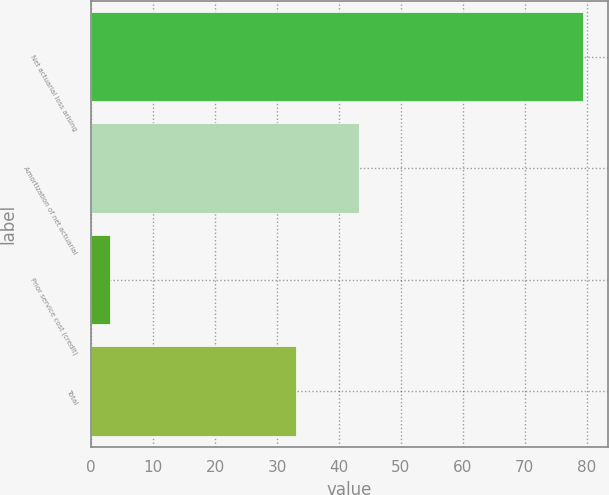<chart> <loc_0><loc_0><loc_500><loc_500><bar_chart><fcel>Net actuarial loss arising<fcel>Amortization of net actuarial<fcel>Prior service cost (credit)<fcel>Total<nl><fcel>79.4<fcel>43.3<fcel>3.1<fcel>33<nl></chart> 